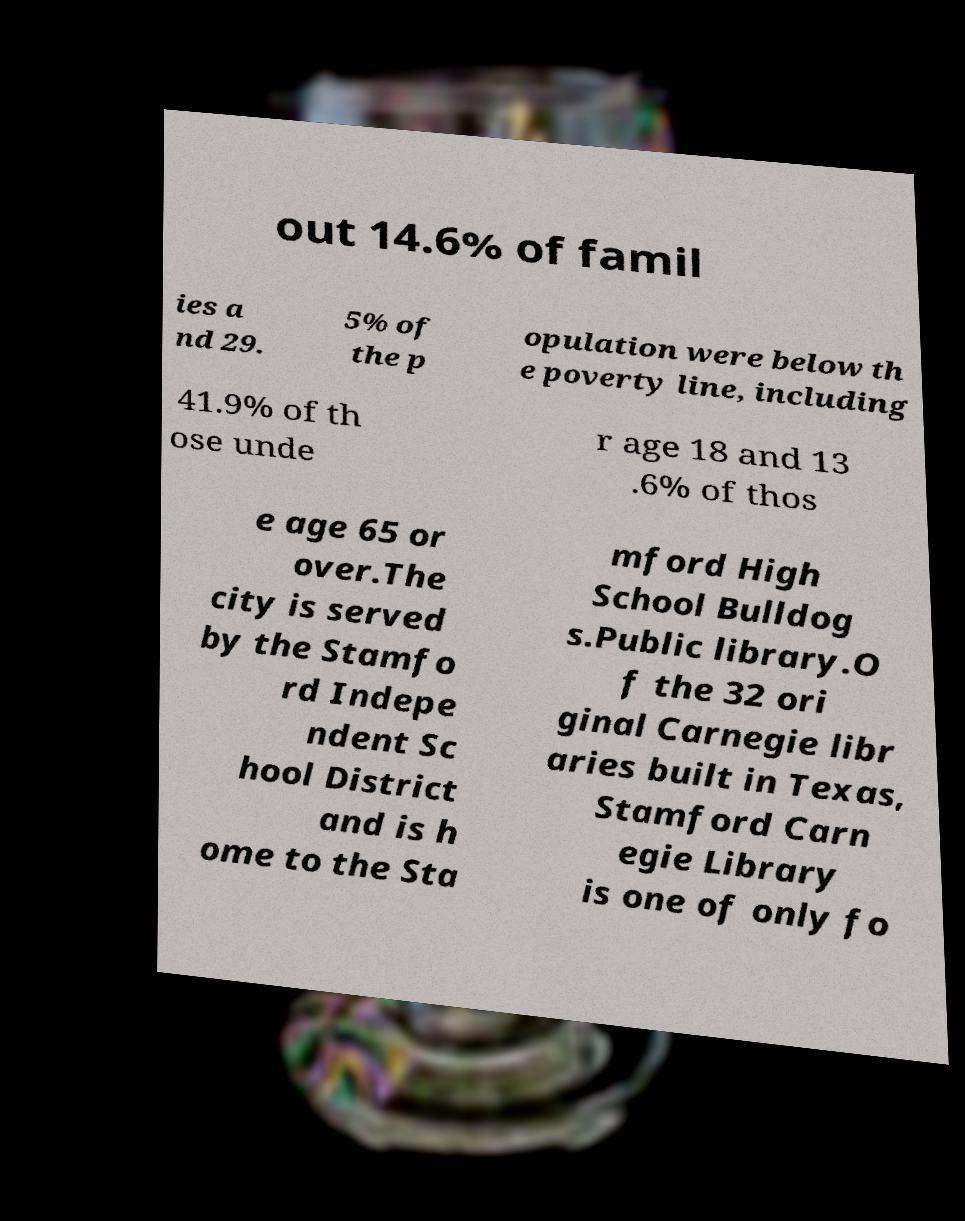Can you read and provide the text displayed in the image?This photo seems to have some interesting text. Can you extract and type it out for me? out 14.6% of famil ies a nd 29. 5% of the p opulation were below th e poverty line, including 41.9% of th ose unde r age 18 and 13 .6% of thos e age 65 or over.The city is served by the Stamfo rd Indepe ndent Sc hool District and is h ome to the Sta mford High School Bulldog s.Public library.O f the 32 ori ginal Carnegie libr aries built in Texas, Stamford Carn egie Library is one of only fo 